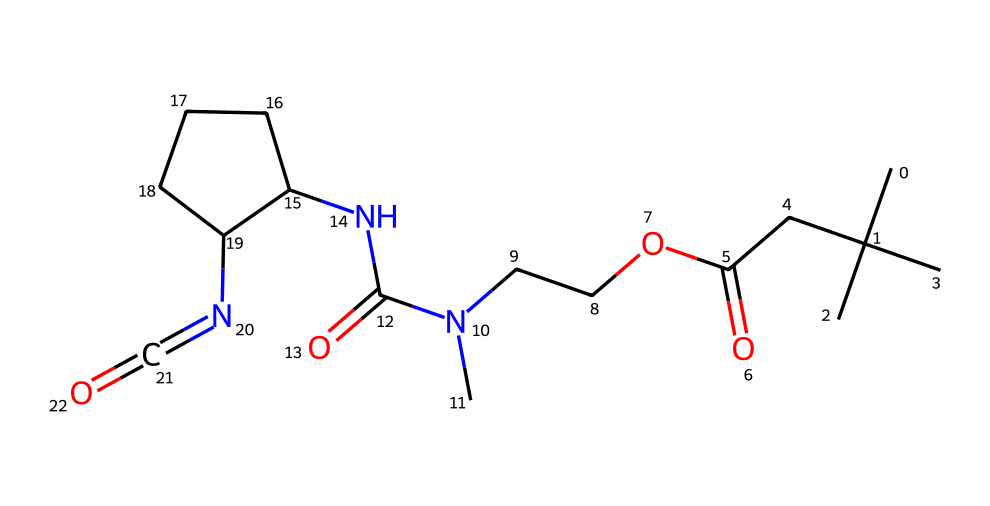What is the molecular formula of this chemical? To determine the molecular formula, count the number of each type of atom represented by the SMILES. The chemical structure includes: 10 carbon (C) atoms, 16 hydrogen (H) atoms, 4 nitrogen (N) atoms, and 4 oxygen (O) atoms. This means the molecular formula is C10H16N4O4.
Answer: C10H16N4O4 How many nitrogen atoms are present? By examining the SMILES, there are four nitrogen (N) atoms in the structure, which can be identified by counting the 'N' symbols in the representation.
Answer: 4 Is this chemical primarily an amine or an amide? The structure contains multiple nitrogen atoms bonded to carbonyl (C=O) groups, which indicates the presence of amides. The amines would appear simpler without these functional groups. Hence, this compound is primarily an amide.
Answer: amide What functional group is represented by the -C(=O)O part? The -C(=O)O represents a carboxylic acid functional group, indicated by the presence of a carbon moiety double-bonded to an oxygen and also singly bonded to a hydroxyl group (-OH). This is characteristic of acids.
Answer: carboxylic acid Does this chemical have any isocyanate groups? The presence of N=C=O clearly indicates an isocyanate group. This is evident as 'N' is double-bonded to 'C', which is double-bonded to 'O', qualifying it as an isocyanate.
Answer: yes What type of bonding interactions are likely prevalent in this chemical? Given the presence of multiple nitrogen and oxygen atoms along with carbon chains in the structure, it is likely that hydrogen bonding and dipole-dipole interactions dominate due to the polar nature of these functional groups.
Answer: hydrogen bonding and dipole-dipole interactions 